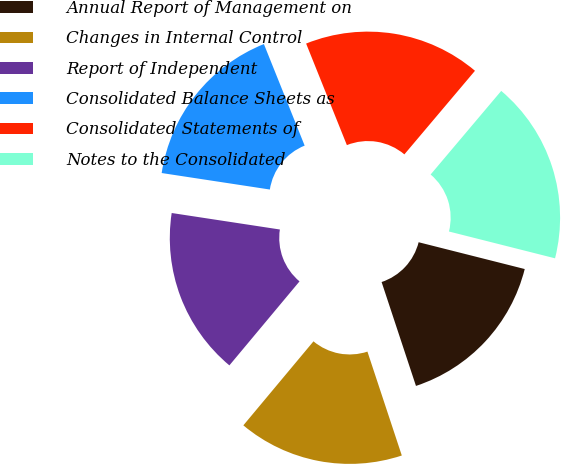<chart> <loc_0><loc_0><loc_500><loc_500><pie_chart><fcel>Annual Report of Management on<fcel>Changes in Internal Control<fcel>Report of Independent<fcel>Consolidated Balance Sheets as<fcel>Consolidated Statements of<fcel>Notes to the Consolidated<nl><fcel>15.98%<fcel>16.16%<fcel>16.34%<fcel>16.52%<fcel>17.24%<fcel>17.78%<nl></chart> 